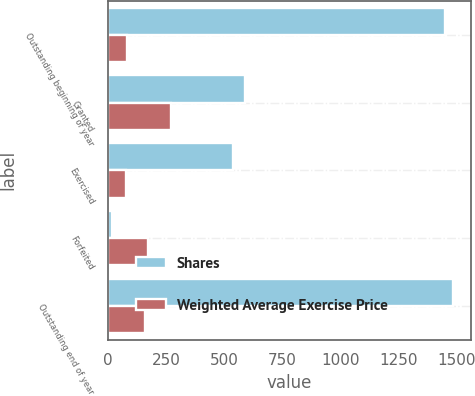Convert chart. <chart><loc_0><loc_0><loc_500><loc_500><stacked_bar_chart><ecel><fcel>Outstanding beginning of year<fcel>Granted<fcel>Exercised<fcel>Forfeited<fcel>Outstanding end of year<nl><fcel>Shares<fcel>1451<fcel>587<fcel>536<fcel>16<fcel>1486<nl><fcel>Weighted Average Exercise Price<fcel>82.56<fcel>268.73<fcel>76.78<fcel>173.05<fcel>157.07<nl></chart> 